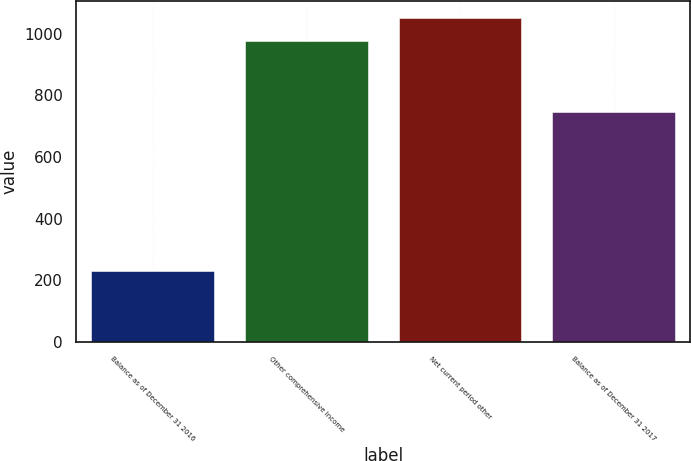Convert chart. <chart><loc_0><loc_0><loc_500><loc_500><bar_chart><fcel>Balance as of December 31 2016<fcel>Other comprehensive income<fcel>Net current period other<fcel>Balance as of December 31 2017<nl><fcel>230<fcel>978<fcel>1052.8<fcel>748<nl></chart> 